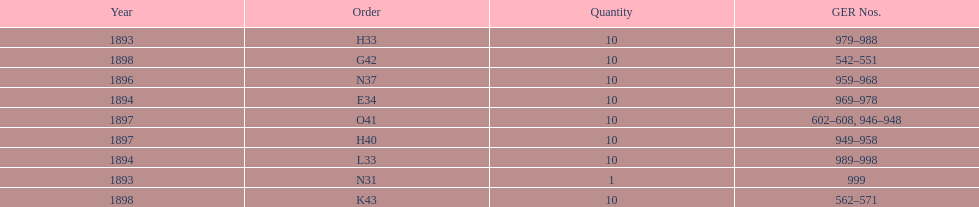Was the year of g42 1894 or 1898? 1898. 